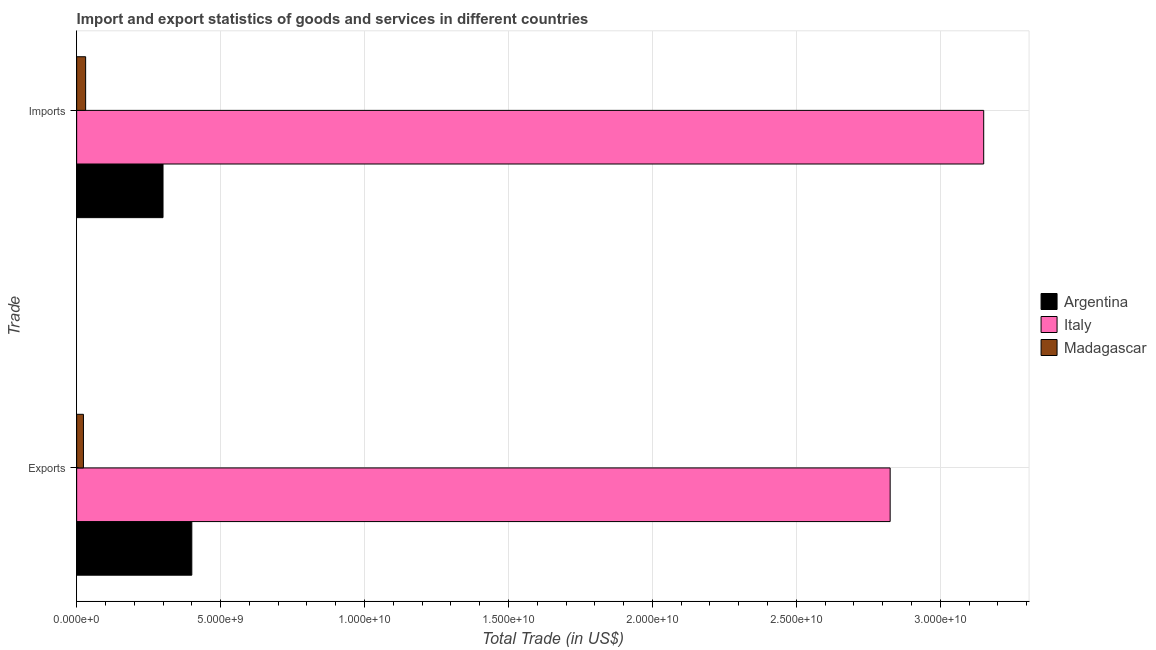How many different coloured bars are there?
Offer a terse response. 3. How many groups of bars are there?
Keep it short and to the point. 2. How many bars are there on the 2nd tick from the top?
Ensure brevity in your answer.  3. How many bars are there on the 2nd tick from the bottom?
Provide a short and direct response. 3. What is the label of the 2nd group of bars from the top?
Make the answer very short. Exports. What is the imports of goods and services in Madagascar?
Your response must be concise. 3.12e+08. Across all countries, what is the maximum imports of goods and services?
Make the answer very short. 3.15e+1. Across all countries, what is the minimum export of goods and services?
Your answer should be compact. 2.36e+08. In which country was the export of goods and services maximum?
Your answer should be compact. Italy. In which country was the imports of goods and services minimum?
Give a very brief answer. Madagascar. What is the total imports of goods and services in the graph?
Make the answer very short. 3.48e+1. What is the difference between the imports of goods and services in Italy and that in Madagascar?
Your answer should be compact. 3.12e+1. What is the difference between the export of goods and services in Argentina and the imports of goods and services in Italy?
Your answer should be compact. -2.75e+1. What is the average imports of goods and services per country?
Make the answer very short. 1.16e+1. What is the difference between the export of goods and services and imports of goods and services in Argentina?
Ensure brevity in your answer.  1.00e+09. In how many countries, is the export of goods and services greater than 8000000000 US$?
Provide a short and direct response. 1. What is the ratio of the imports of goods and services in Argentina to that in Madagascar?
Keep it short and to the point. 9.61. In how many countries, is the imports of goods and services greater than the average imports of goods and services taken over all countries?
Keep it short and to the point. 1. What does the 2nd bar from the top in Exports represents?
Offer a very short reply. Italy. What does the 1st bar from the bottom in Exports represents?
Offer a terse response. Argentina. How many bars are there?
Make the answer very short. 6. How many countries are there in the graph?
Keep it short and to the point. 3. How many legend labels are there?
Provide a short and direct response. 3. What is the title of the graph?
Make the answer very short. Import and export statistics of goods and services in different countries. What is the label or title of the X-axis?
Keep it short and to the point. Total Trade (in US$). What is the label or title of the Y-axis?
Provide a short and direct response. Trade. What is the Total Trade (in US$) in Argentina in Exports?
Provide a short and direct response. 4.00e+09. What is the Total Trade (in US$) of Italy in Exports?
Give a very brief answer. 2.83e+1. What is the Total Trade (in US$) in Madagascar in Exports?
Provide a short and direct response. 2.36e+08. What is the Total Trade (in US$) of Argentina in Imports?
Ensure brevity in your answer.  3.00e+09. What is the Total Trade (in US$) in Italy in Imports?
Offer a very short reply. 3.15e+1. What is the Total Trade (in US$) of Madagascar in Imports?
Provide a short and direct response. 3.12e+08. Across all Trade, what is the maximum Total Trade (in US$) in Argentina?
Keep it short and to the point. 4.00e+09. Across all Trade, what is the maximum Total Trade (in US$) in Italy?
Offer a very short reply. 3.15e+1. Across all Trade, what is the maximum Total Trade (in US$) of Madagascar?
Offer a terse response. 3.12e+08. Across all Trade, what is the minimum Total Trade (in US$) in Argentina?
Provide a short and direct response. 3.00e+09. Across all Trade, what is the minimum Total Trade (in US$) of Italy?
Ensure brevity in your answer.  2.83e+1. Across all Trade, what is the minimum Total Trade (in US$) in Madagascar?
Make the answer very short. 2.36e+08. What is the total Total Trade (in US$) of Argentina in the graph?
Ensure brevity in your answer.  7.00e+09. What is the total Total Trade (in US$) in Italy in the graph?
Your response must be concise. 5.98e+1. What is the total Total Trade (in US$) in Madagascar in the graph?
Give a very brief answer. 5.48e+08. What is the difference between the Total Trade (in US$) in Argentina in Exports and that in Imports?
Your answer should be compact. 1.00e+09. What is the difference between the Total Trade (in US$) in Italy in Exports and that in Imports?
Keep it short and to the point. -3.25e+09. What is the difference between the Total Trade (in US$) of Madagascar in Exports and that in Imports?
Keep it short and to the point. -7.66e+07. What is the difference between the Total Trade (in US$) of Argentina in Exports and the Total Trade (in US$) of Italy in Imports?
Your answer should be compact. -2.75e+1. What is the difference between the Total Trade (in US$) of Argentina in Exports and the Total Trade (in US$) of Madagascar in Imports?
Offer a very short reply. 3.69e+09. What is the difference between the Total Trade (in US$) in Italy in Exports and the Total Trade (in US$) in Madagascar in Imports?
Give a very brief answer. 2.79e+1. What is the average Total Trade (in US$) in Argentina per Trade?
Provide a short and direct response. 3.50e+09. What is the average Total Trade (in US$) in Italy per Trade?
Provide a succinct answer. 2.99e+1. What is the average Total Trade (in US$) of Madagascar per Trade?
Your answer should be very brief. 2.74e+08. What is the difference between the Total Trade (in US$) of Argentina and Total Trade (in US$) of Italy in Exports?
Offer a very short reply. -2.43e+1. What is the difference between the Total Trade (in US$) of Argentina and Total Trade (in US$) of Madagascar in Exports?
Provide a short and direct response. 3.76e+09. What is the difference between the Total Trade (in US$) of Italy and Total Trade (in US$) of Madagascar in Exports?
Make the answer very short. 2.80e+1. What is the difference between the Total Trade (in US$) in Argentina and Total Trade (in US$) in Italy in Imports?
Provide a short and direct response. -2.85e+1. What is the difference between the Total Trade (in US$) of Argentina and Total Trade (in US$) of Madagascar in Imports?
Make the answer very short. 2.69e+09. What is the difference between the Total Trade (in US$) of Italy and Total Trade (in US$) of Madagascar in Imports?
Keep it short and to the point. 3.12e+1. What is the ratio of the Total Trade (in US$) of Argentina in Exports to that in Imports?
Ensure brevity in your answer.  1.33. What is the ratio of the Total Trade (in US$) in Italy in Exports to that in Imports?
Make the answer very short. 0.9. What is the ratio of the Total Trade (in US$) in Madagascar in Exports to that in Imports?
Offer a very short reply. 0.75. What is the difference between the highest and the second highest Total Trade (in US$) of Argentina?
Ensure brevity in your answer.  1.00e+09. What is the difference between the highest and the second highest Total Trade (in US$) of Italy?
Make the answer very short. 3.25e+09. What is the difference between the highest and the second highest Total Trade (in US$) in Madagascar?
Make the answer very short. 7.66e+07. What is the difference between the highest and the lowest Total Trade (in US$) of Argentina?
Your answer should be very brief. 1.00e+09. What is the difference between the highest and the lowest Total Trade (in US$) in Italy?
Give a very brief answer. 3.25e+09. What is the difference between the highest and the lowest Total Trade (in US$) of Madagascar?
Offer a very short reply. 7.66e+07. 